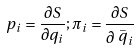<formula> <loc_0><loc_0><loc_500><loc_500>p _ { i } = \frac { \partial S } { \partial q _ { i } } ; \pi _ { i } = \frac { \partial S } { \partial \stackrel { \_ } { q } _ { i } }</formula> 